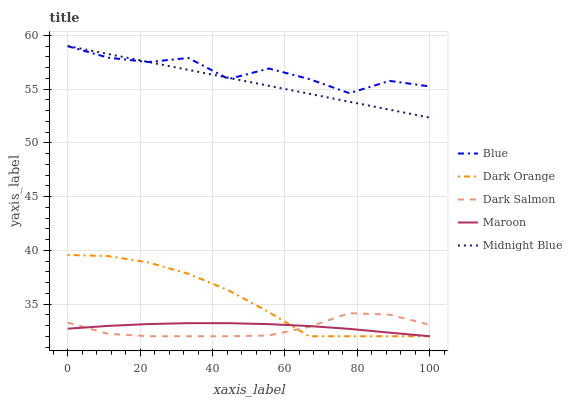Does Dark Salmon have the minimum area under the curve?
Answer yes or no. Yes. Does Blue have the maximum area under the curve?
Answer yes or no. Yes. Does Dark Orange have the minimum area under the curve?
Answer yes or no. No. Does Dark Orange have the maximum area under the curve?
Answer yes or no. No. Is Midnight Blue the smoothest?
Answer yes or no. Yes. Is Blue the roughest?
Answer yes or no. Yes. Is Dark Orange the smoothest?
Answer yes or no. No. Is Dark Orange the roughest?
Answer yes or no. No. Does Dark Orange have the lowest value?
Answer yes or no. Yes. Does Midnight Blue have the lowest value?
Answer yes or no. No. Does Midnight Blue have the highest value?
Answer yes or no. Yes. Does Dark Orange have the highest value?
Answer yes or no. No. Is Maroon less than Midnight Blue?
Answer yes or no. Yes. Is Midnight Blue greater than Maroon?
Answer yes or no. Yes. Does Blue intersect Midnight Blue?
Answer yes or no. Yes. Is Blue less than Midnight Blue?
Answer yes or no. No. Is Blue greater than Midnight Blue?
Answer yes or no. No. Does Maroon intersect Midnight Blue?
Answer yes or no. No. 